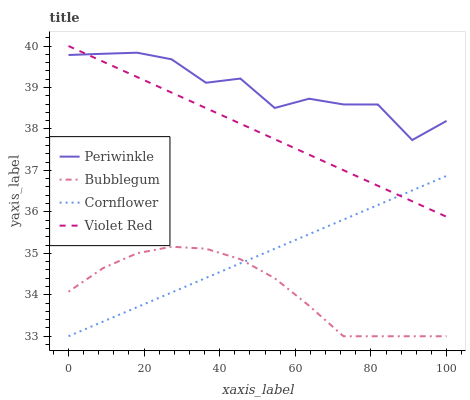Does Bubblegum have the minimum area under the curve?
Answer yes or no. Yes. Does Periwinkle have the maximum area under the curve?
Answer yes or no. Yes. Does Violet Red have the minimum area under the curve?
Answer yes or no. No. Does Violet Red have the maximum area under the curve?
Answer yes or no. No. Is Cornflower the smoothest?
Answer yes or no. Yes. Is Periwinkle the roughest?
Answer yes or no. Yes. Is Violet Red the smoothest?
Answer yes or no. No. Is Violet Red the roughest?
Answer yes or no. No. Does Violet Red have the lowest value?
Answer yes or no. No. Does Violet Red have the highest value?
Answer yes or no. Yes. Does Periwinkle have the highest value?
Answer yes or no. No. Is Cornflower less than Periwinkle?
Answer yes or no. Yes. Is Violet Red greater than Bubblegum?
Answer yes or no. Yes. Does Bubblegum intersect Cornflower?
Answer yes or no. Yes. Is Bubblegum less than Cornflower?
Answer yes or no. No. Is Bubblegum greater than Cornflower?
Answer yes or no. No. Does Cornflower intersect Periwinkle?
Answer yes or no. No. 